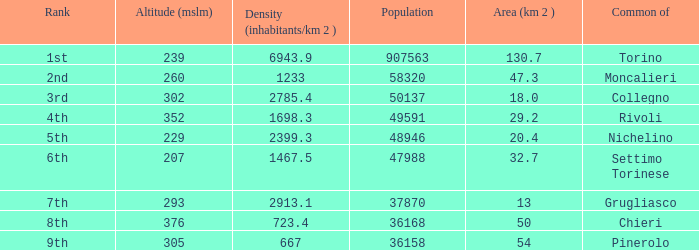The common of Chieri has what population density? 723.4. 